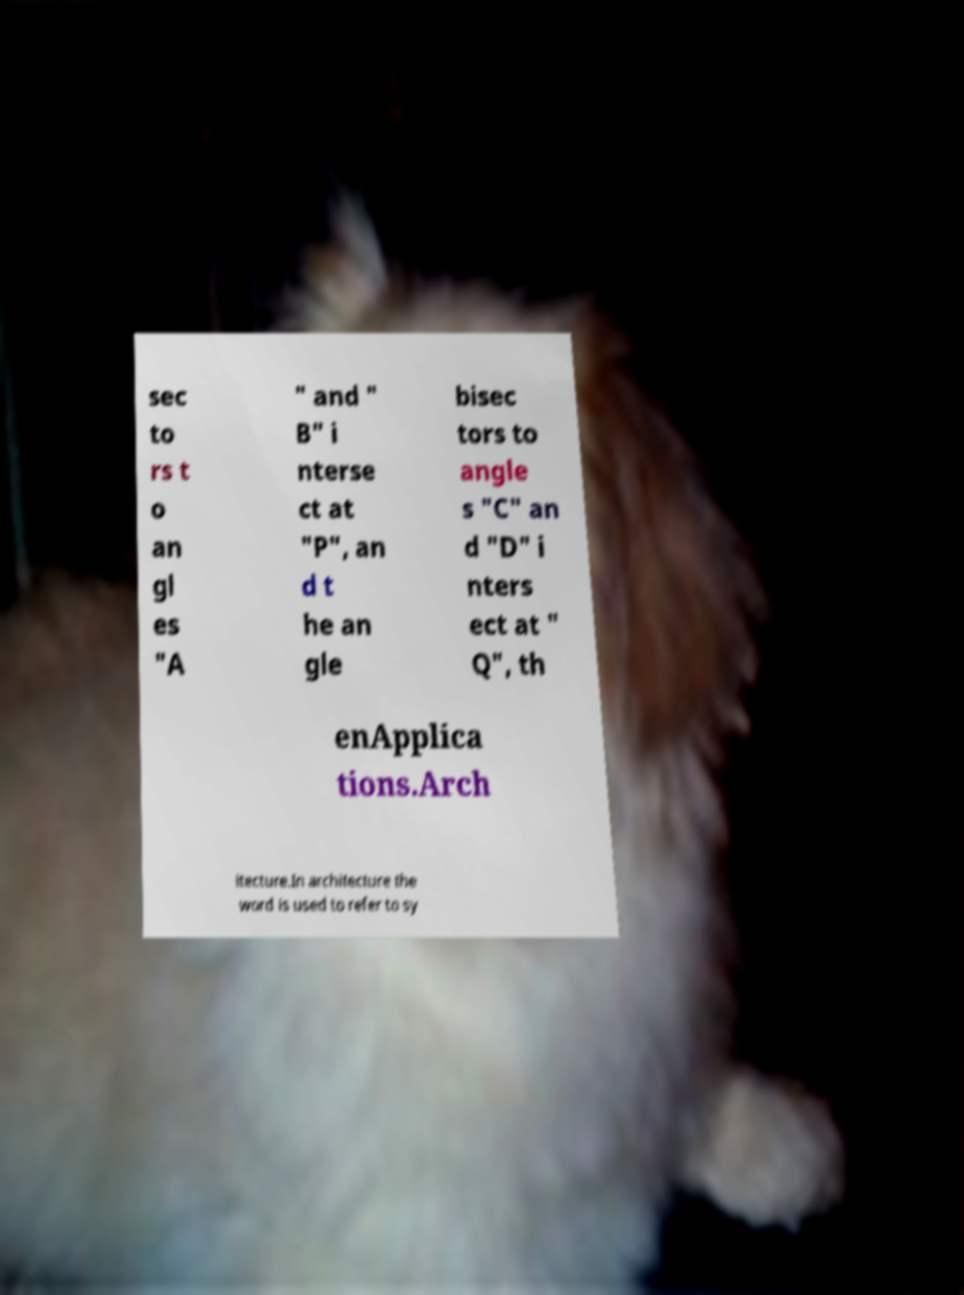Could you assist in decoding the text presented in this image and type it out clearly? sec to rs t o an gl es "A " and " B" i nterse ct at "P", an d t he an gle bisec tors to angle s "C" an d "D" i nters ect at " Q", th enApplica tions.Arch itecture.In architecture the word is used to refer to sy 